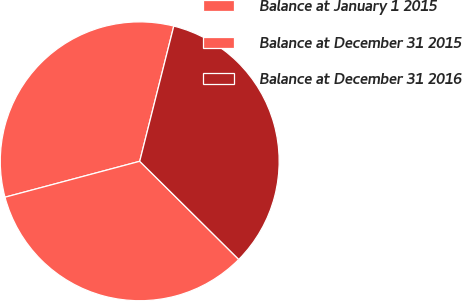Convert chart. <chart><loc_0><loc_0><loc_500><loc_500><pie_chart><fcel>Balance at January 1 2015<fcel>Balance at December 31 2015<fcel>Balance at December 31 2016<nl><fcel>33.08%<fcel>33.43%<fcel>33.5%<nl></chart> 